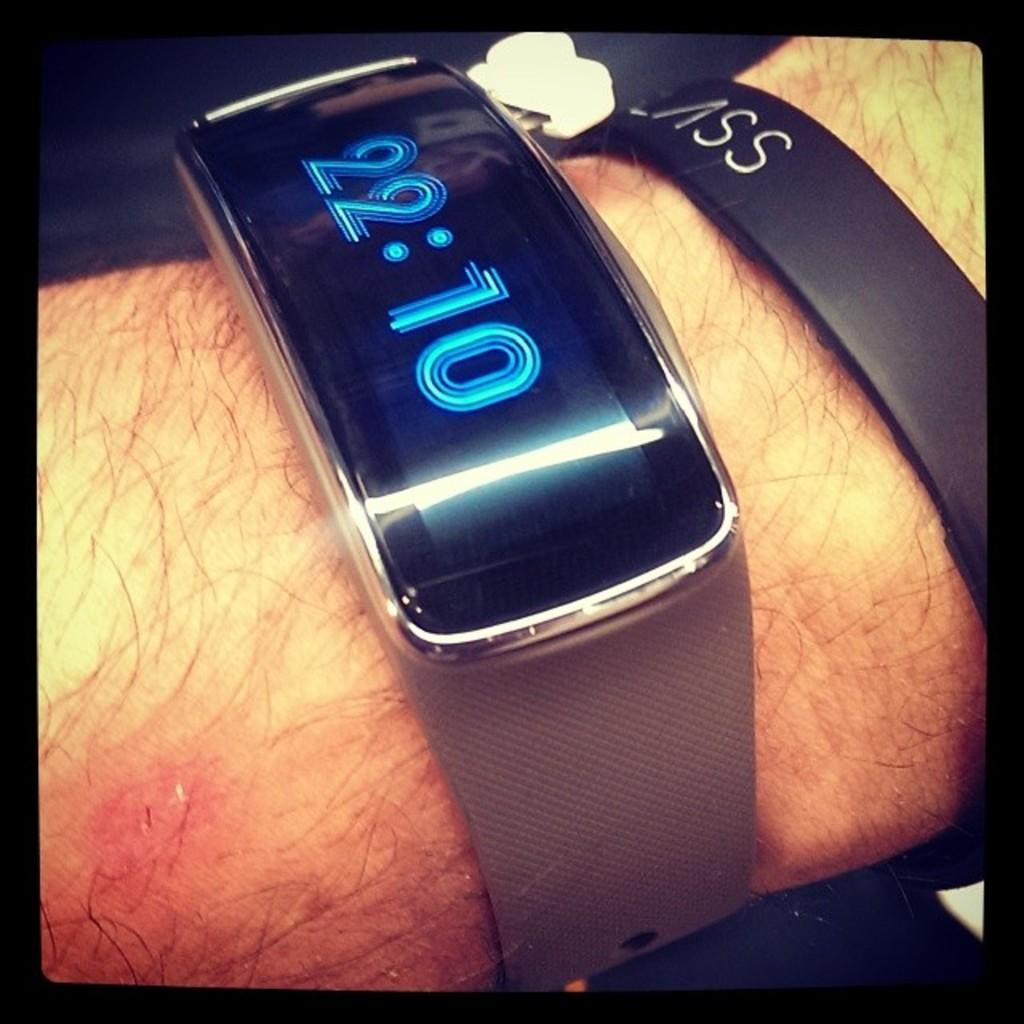<image>
Describe the image concisely. A digital watch displays the time of 22:10. 